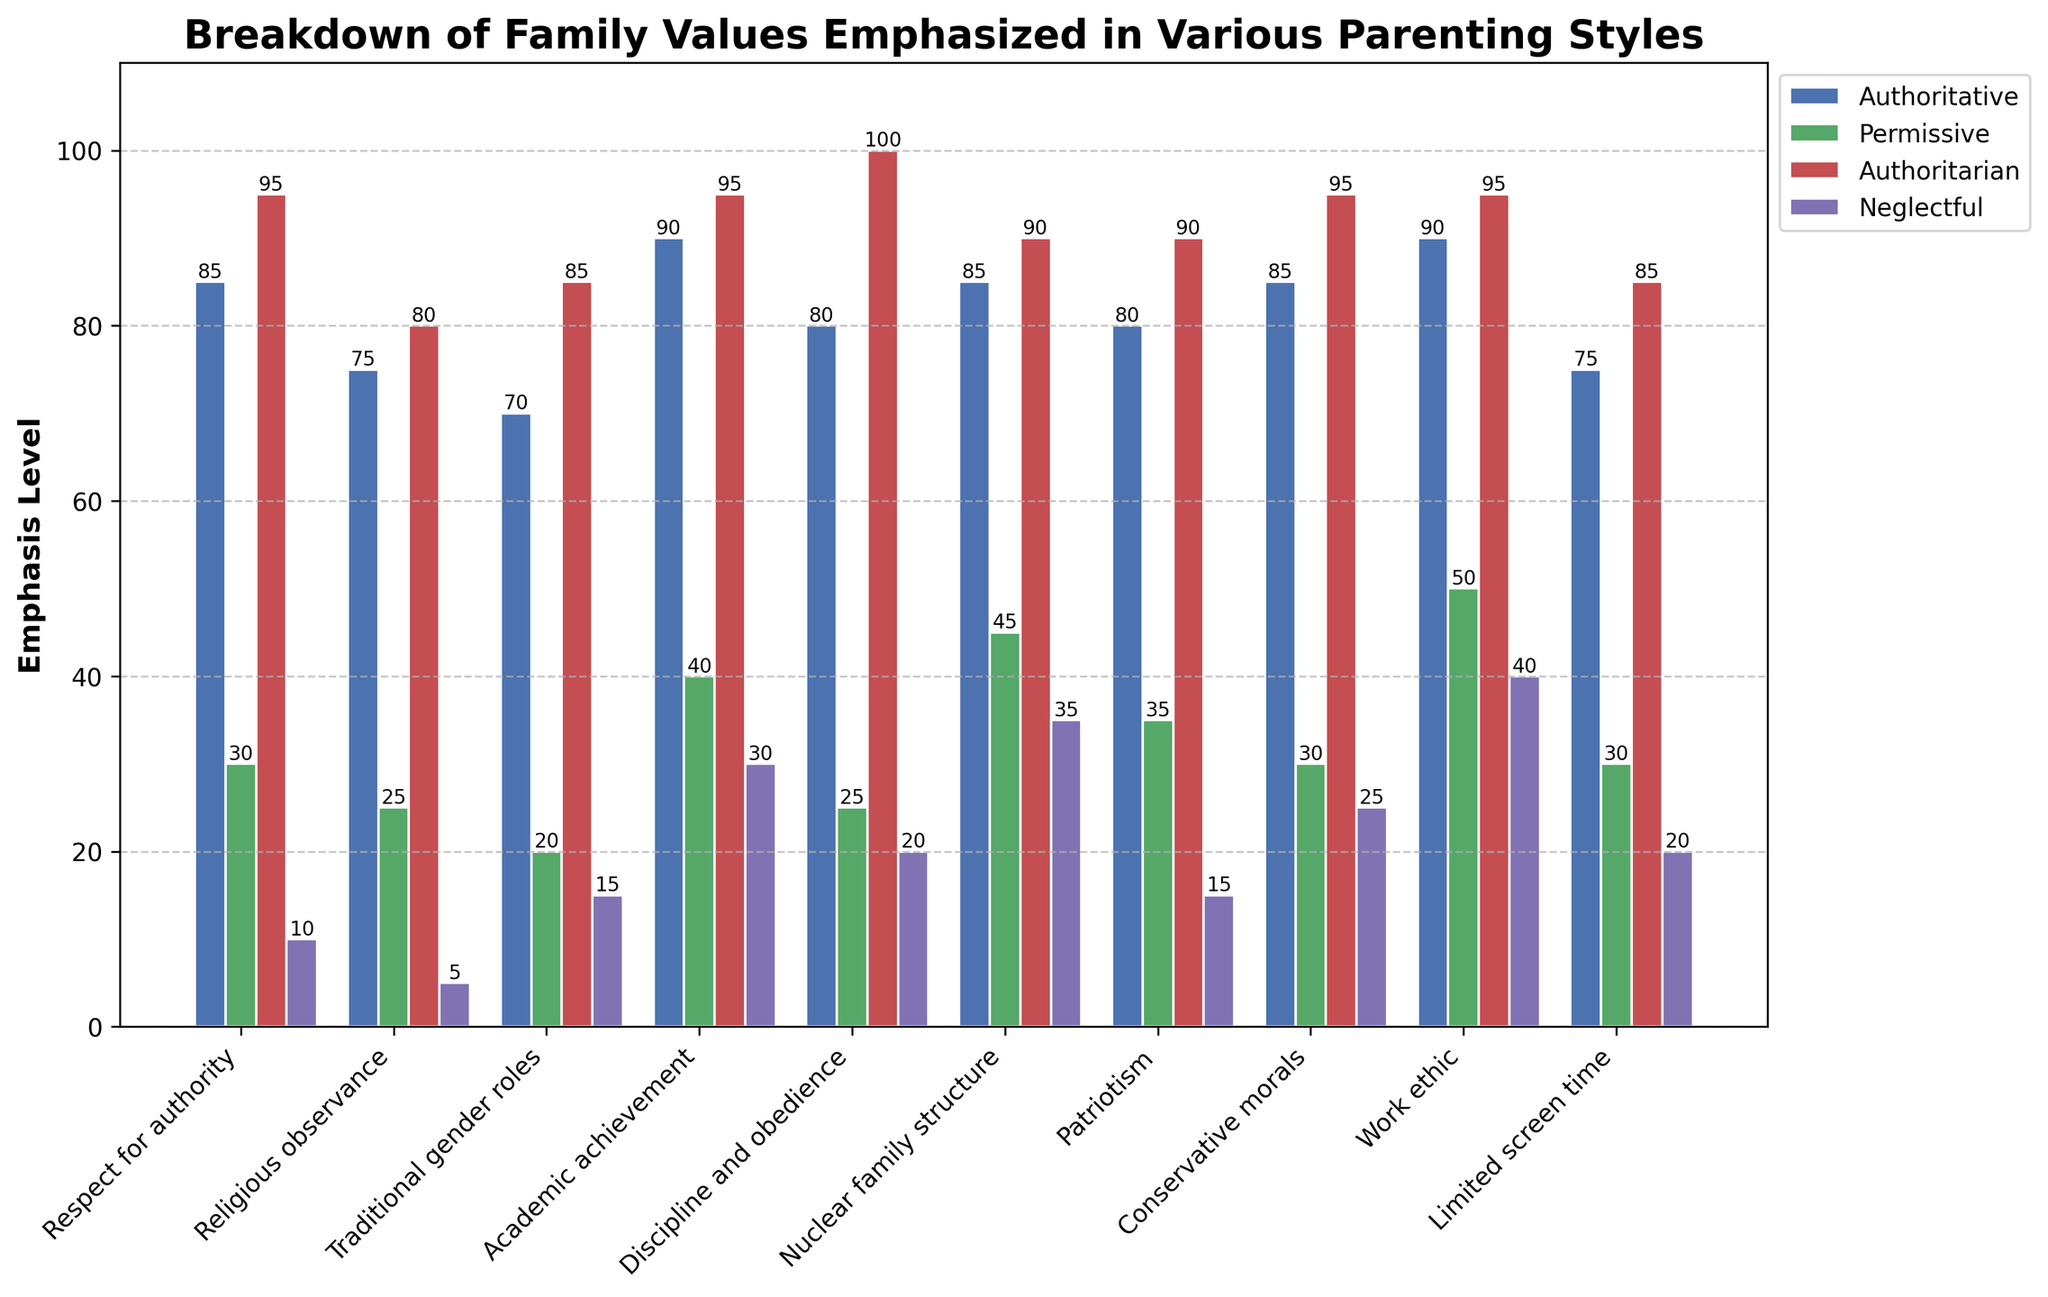What is the difference between the emphasis on "Respect for authority" in Authoritative and Permissive parenting styles? The Authoritative value for "Respect for authority" is 85, while Permissive is 30. The difference is 85 - 30 = 55.
Answer: 55 Which parenting style places the highest emphasis on "Discipline and obedience"? By comparing the heights of the bars for "Discipline and obedience," we see that Authoritarian has the highest value at 100.
Answer: Authoritarian What is the average emphasis value for "Academic achievement" across all parenting styles? The "Academic achievement" values for each style are Authoritative (90), Permissive (40), Authoritarian (95), and Neglectful (30). The average is (90 + 40 + 95 + 30) / 4 = 63.75.
Answer: 63.75 Is the emphasis on "Work ethic" higher in Authoritative parenting or Neglectful parenting? The emphasis on "Work ethic" is 90 in Authoritative and 40 in Neglectful, making it higher in Authoritative.
Answer: Authoritative Which family value has the lowest emphasis in the Permissive parenting style? By visually inspecting the bars for Permissive, "Religious observance" has the lowest value at 25.
Answer: Religious observance How much more emphasis is placed on "Patriotism" in Authoritarian parenting compared to Neglectful parenting? Authoritarian places an emphasis of 90 on "Patriotism," while Neglectful places 15. The difference is 90 - 15 = 75.
Answer: 75 What value does the Authoritative parenting style place on "Traditional gender roles," and how does it compare to the Neglectful style? Authoritative places a value of 70, while Neglectful places 15. This means Authoritative is higher by 70 - 15 = 55.
Answer: 55 Which family value does the Authoritative and Authoritarian parenting styles emphasize equally? By comparing the heights, both styles emphasize "Academic achievement" equally at 95.
Answer: Academic achievement What is the sum of the emphasis placed on "Nuclear family structure" across all parenting styles? The values are Authoritative (85), Permissive (45), Authoritarian (90), and Neglectful (35). The sum is 85 + 45 + 90 + 35 = 255.
Answer: 255 How does the emphasis on "Limited screen time" in Permissive parenting compare to Authoritarian parenting? The emphasis on "Limited screen time" in Permissive is 30, while in Authoritarian it is 85. Thus, Authoritarian is significantly higher.
Answer: Authoritarian 